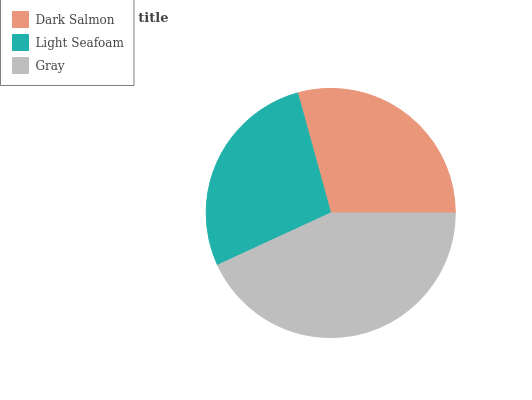Is Light Seafoam the minimum?
Answer yes or no. Yes. Is Gray the maximum?
Answer yes or no. Yes. Is Gray the minimum?
Answer yes or no. No. Is Light Seafoam the maximum?
Answer yes or no. No. Is Gray greater than Light Seafoam?
Answer yes or no. Yes. Is Light Seafoam less than Gray?
Answer yes or no. Yes. Is Light Seafoam greater than Gray?
Answer yes or no. No. Is Gray less than Light Seafoam?
Answer yes or no. No. Is Dark Salmon the high median?
Answer yes or no. Yes. Is Dark Salmon the low median?
Answer yes or no. Yes. Is Gray the high median?
Answer yes or no. No. Is Light Seafoam the low median?
Answer yes or no. No. 